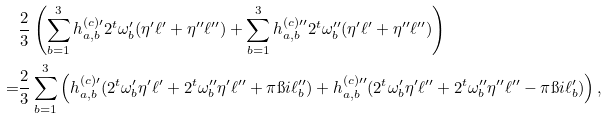Convert formula to latex. <formula><loc_0><loc_0><loc_500><loc_500>& \frac { 2 } { 3 } \left ( \sum _ { b = 1 } ^ { 3 } h ^ { ( c ) \prime } _ { a , b } 2 ^ { t } \omega _ { b } ^ { \prime } ( \eta ^ { \prime } \ell ^ { \prime } + \eta ^ { \prime \prime } \ell ^ { \prime \prime } ) + \sum _ { b = 1 } ^ { 3 } h ^ { ( c ) \prime \prime } _ { a , b } 2 ^ { t } \omega _ { b } ^ { \prime \prime } ( \eta ^ { \prime } \ell ^ { \prime } + \eta ^ { \prime \prime } \ell ^ { \prime \prime } ) \right ) \\ = & \frac { 2 } { 3 } \sum _ { b = 1 } ^ { 3 } \left ( h ^ { ( c ) \prime } _ { a , b } ( 2 ^ { t } \omega _ { b } ^ { \prime } \eta ^ { \prime } \ell ^ { \prime } + 2 ^ { t } \omega _ { b } ^ { \prime \prime } \eta ^ { \prime } \ell ^ { \prime \prime } + \pi \i i \ell ^ { \prime \prime } _ { b } ) + h ^ { ( c ) \prime \prime } _ { a , b } ( 2 ^ { t } \omega _ { b } ^ { \prime } \eta ^ { \prime } \ell ^ { \prime \prime } + 2 ^ { t } \omega _ { b } ^ { \prime \prime } \eta ^ { \prime \prime } \ell ^ { \prime \prime } - \pi \i i \ell ^ { \prime } _ { b } ) \right ) , \\</formula> 